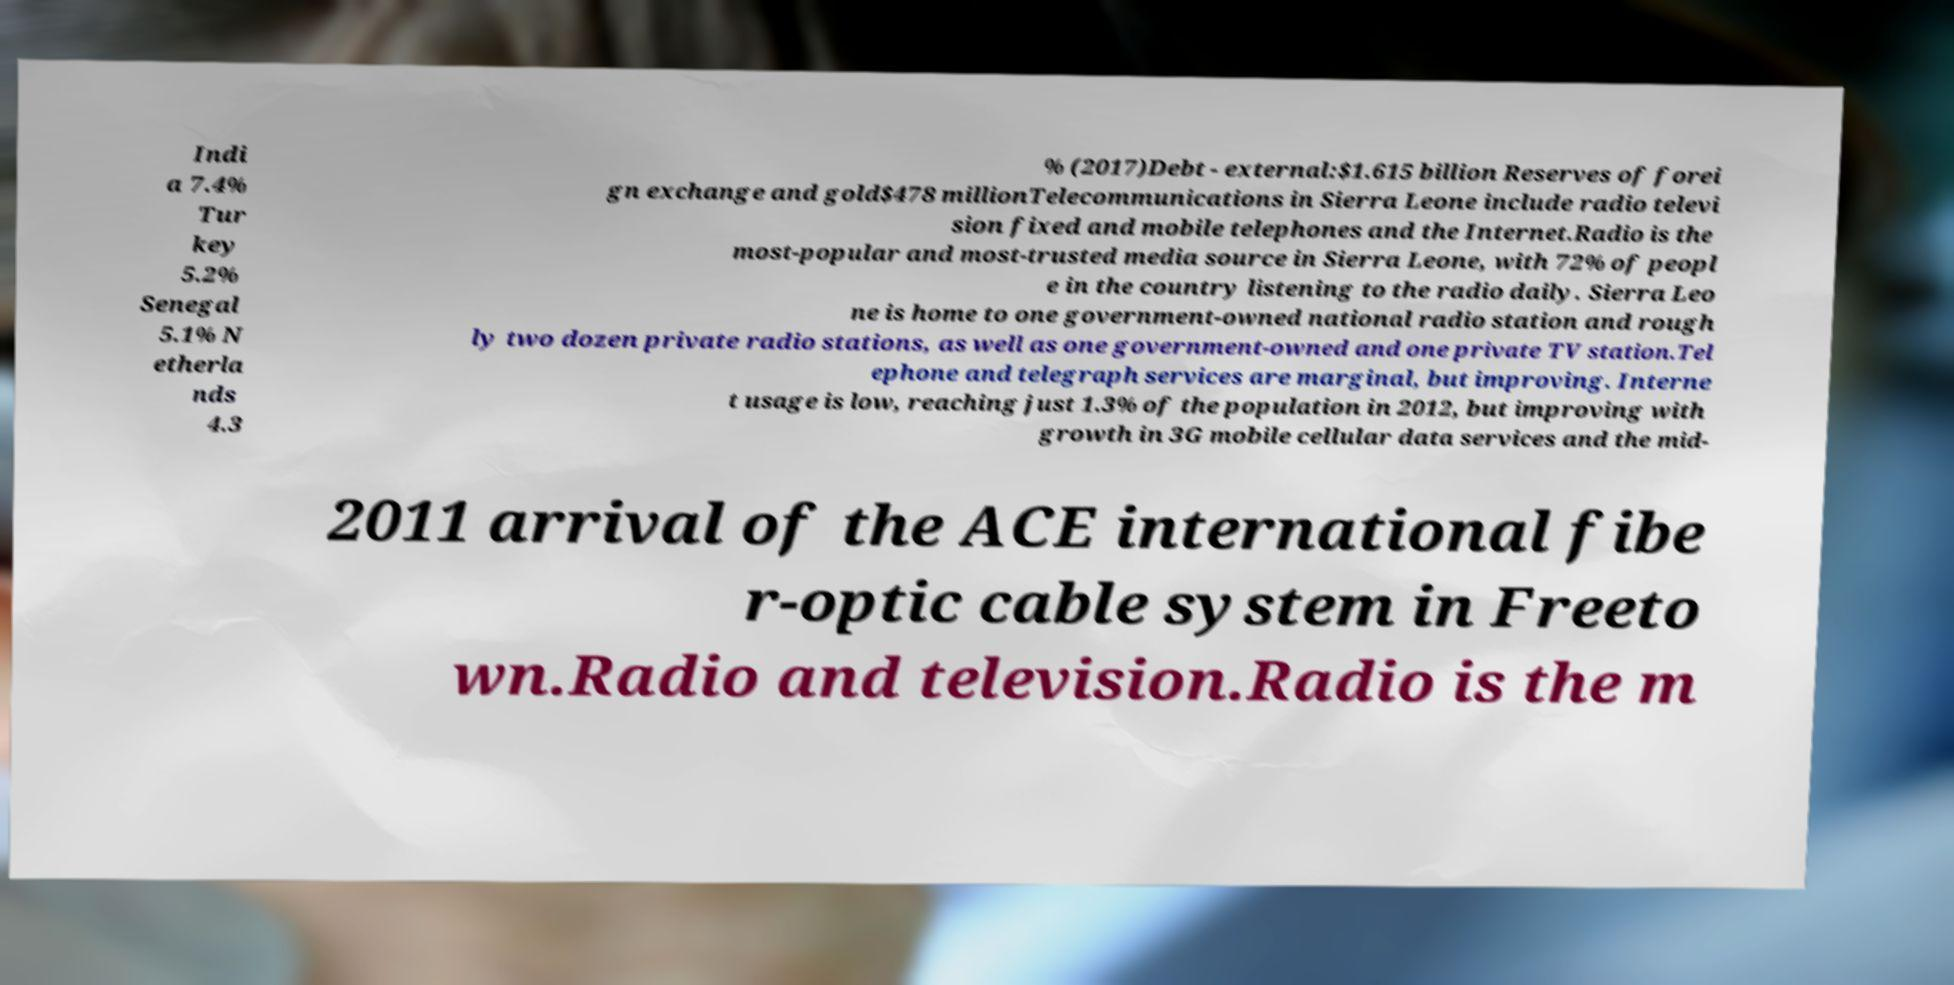Please identify and transcribe the text found in this image. Indi a 7.4% Tur key 5.2% Senegal 5.1% N etherla nds 4.3 % (2017)Debt - external:$1.615 billion Reserves of forei gn exchange and gold$478 millionTelecommunications in Sierra Leone include radio televi sion fixed and mobile telephones and the Internet.Radio is the most-popular and most-trusted media source in Sierra Leone, with 72% of peopl e in the country listening to the radio daily. Sierra Leo ne is home to one government-owned national radio station and rough ly two dozen private radio stations, as well as one government-owned and one private TV station.Tel ephone and telegraph services are marginal, but improving. Interne t usage is low, reaching just 1.3% of the population in 2012, but improving with growth in 3G mobile cellular data services and the mid- 2011 arrival of the ACE international fibe r-optic cable system in Freeto wn.Radio and television.Radio is the m 